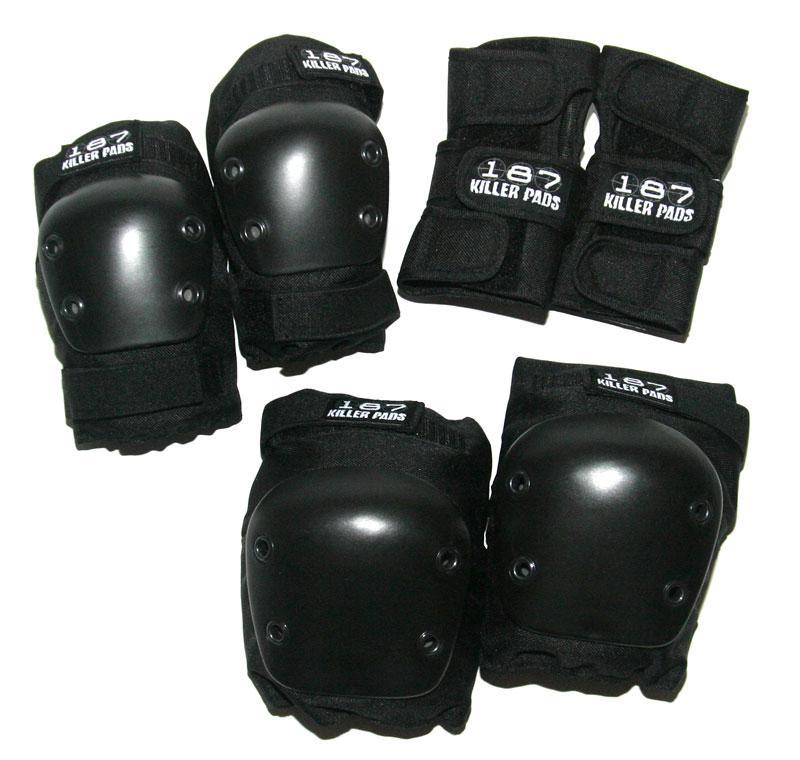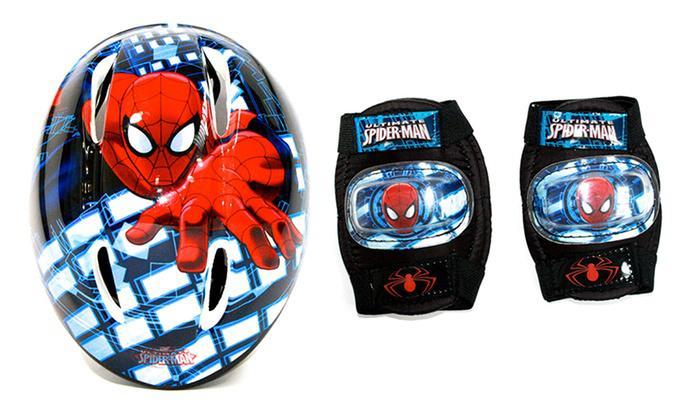The first image is the image on the left, the second image is the image on the right. For the images shown, is this caption "The image on the left has kneepads with only neutral colors such as black and white on it." true? Answer yes or no. Yes. The first image is the image on the left, the second image is the image on the right. Assess this claim about the two images: "An image includes fingerless gloves and two pairs of pads.". Correct or not? Answer yes or no. No. 